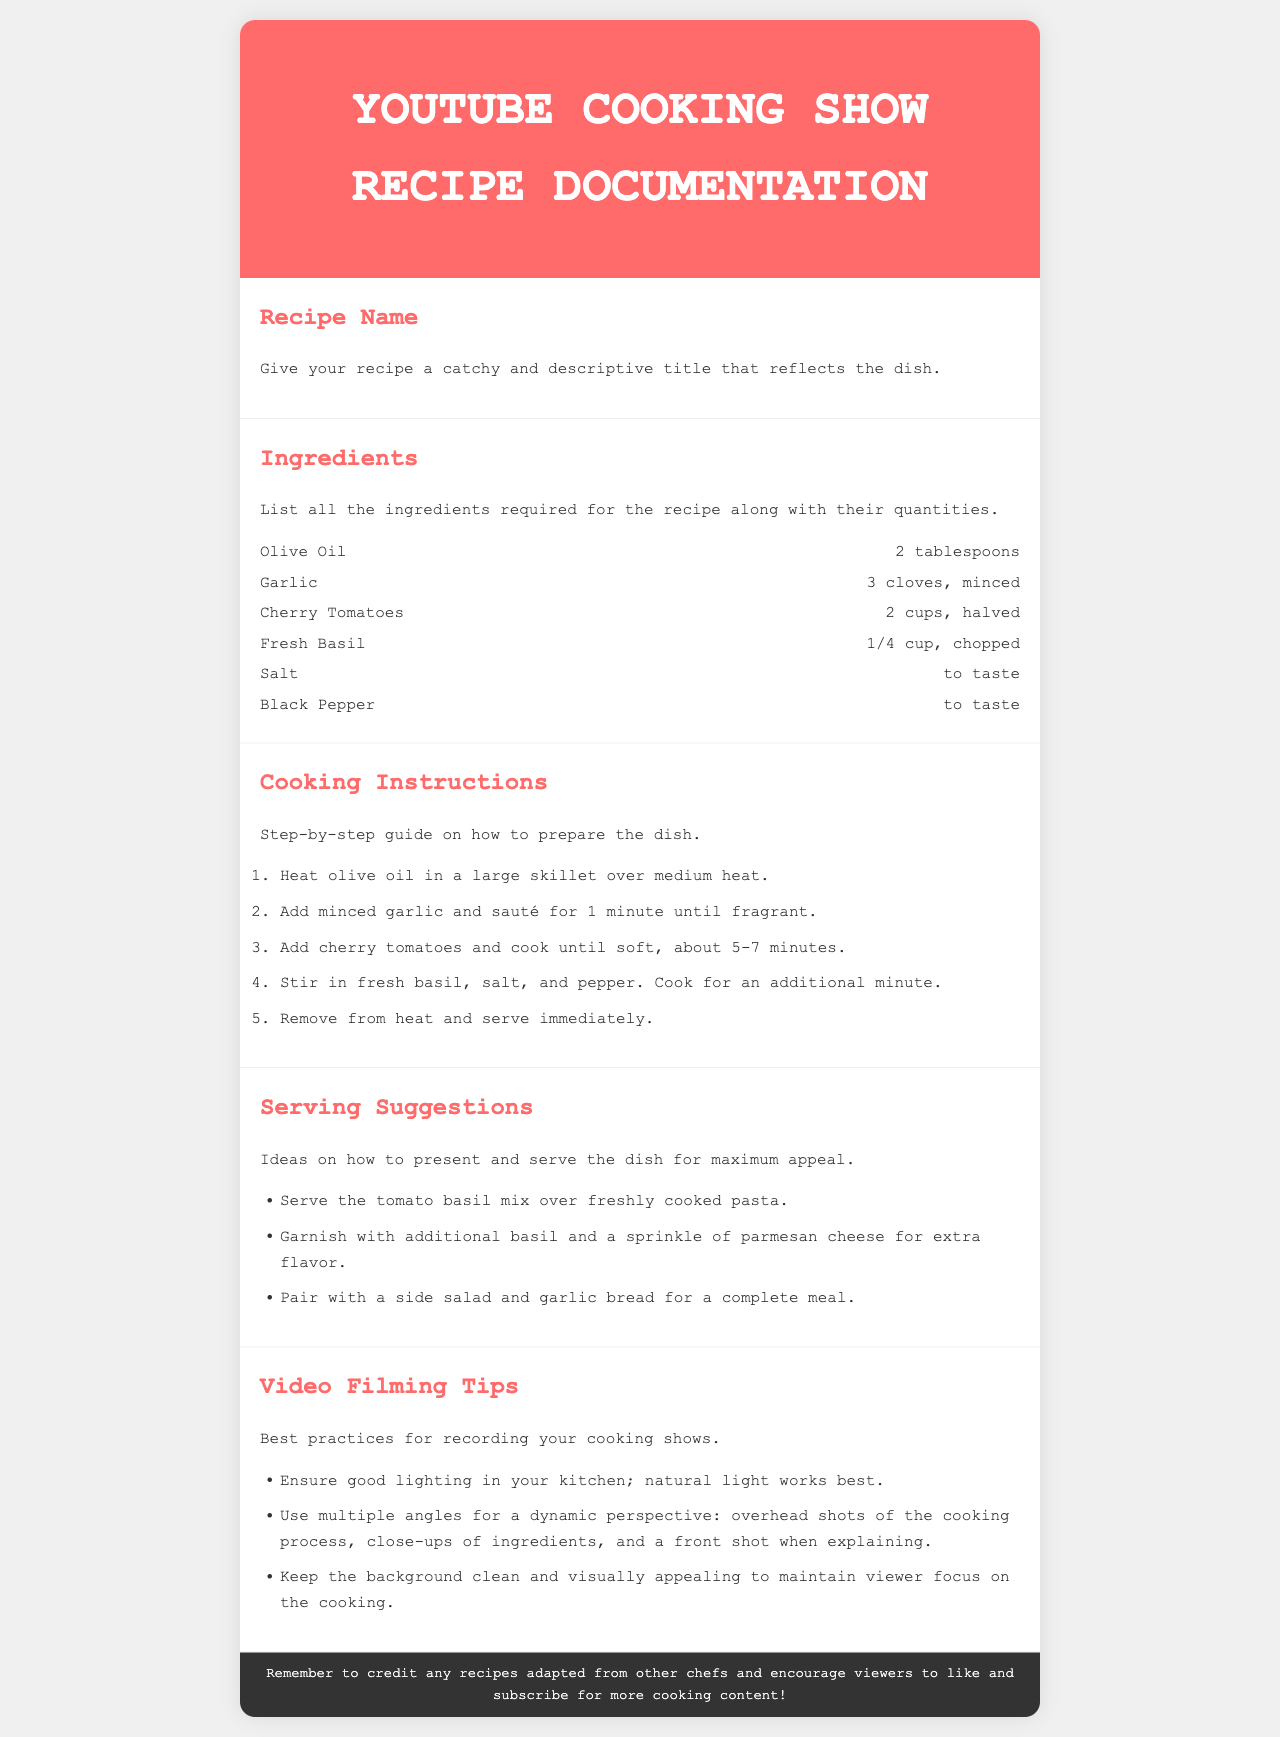What is the recipe name section for? The recipe name section is for giving a catchy and descriptive title that reflects the dish.
Answer: A catchy and descriptive title How many cloves of garlic are required? The ingredients section lists 3 cloves of garlic, minced, as required for the recipe.
Answer: 3 cloves What is the first cooking instruction? The first cooking instruction is to heat olive oil in a large skillet over medium heat.
Answer: Heat olive oil in a large skillet over medium heat What is a serving suggestion for the dish? One serving suggestion is to serve the tomato basil mix over freshly cooked pasta.
Answer: Serve the tomato basil mix over freshly cooked pasta How many cooking instructions are provided? The document includes a total of 5 cooking instructions.
Answer: 5 What is the background color of the document? The background color of the document is light gray #f0f0f0.
Answer: #f0f0f0 What do the video filming tips emphasize? The video filming tips emphasize the importance of good lighting, multiple angles, and a clean background.
Answer: Good lighting, multiple angles, clean background What should you do with recipes adapted from other chefs? You should credit any recipes adapted from other chefs.
Answer: Credit any recipes adapted from other chefs 